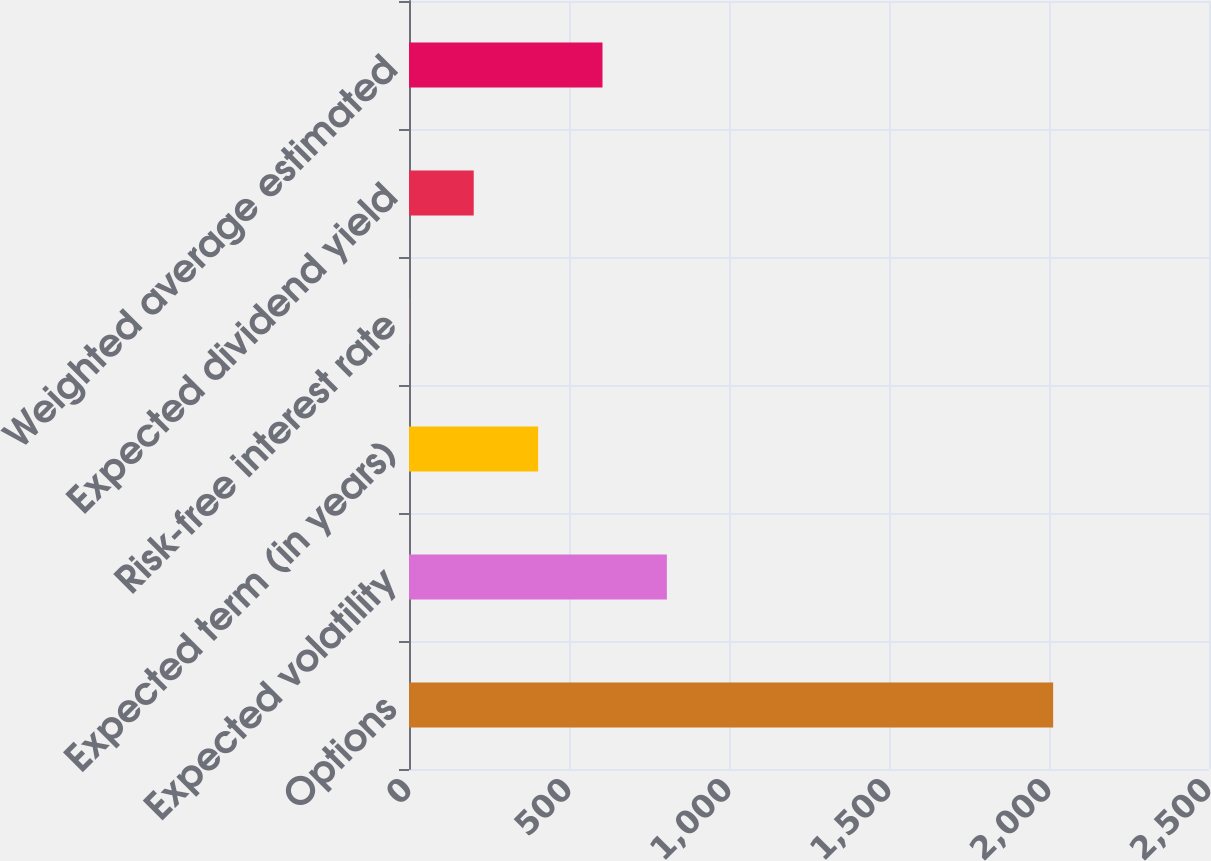Convert chart to OTSL. <chart><loc_0><loc_0><loc_500><loc_500><bar_chart><fcel>Options<fcel>Expected volatility<fcel>Expected term (in years)<fcel>Risk-free interest rate<fcel>Expected dividend yield<fcel>Weighted average estimated<nl><fcel>2013<fcel>805.86<fcel>403.48<fcel>1.1<fcel>202.29<fcel>604.67<nl></chart> 